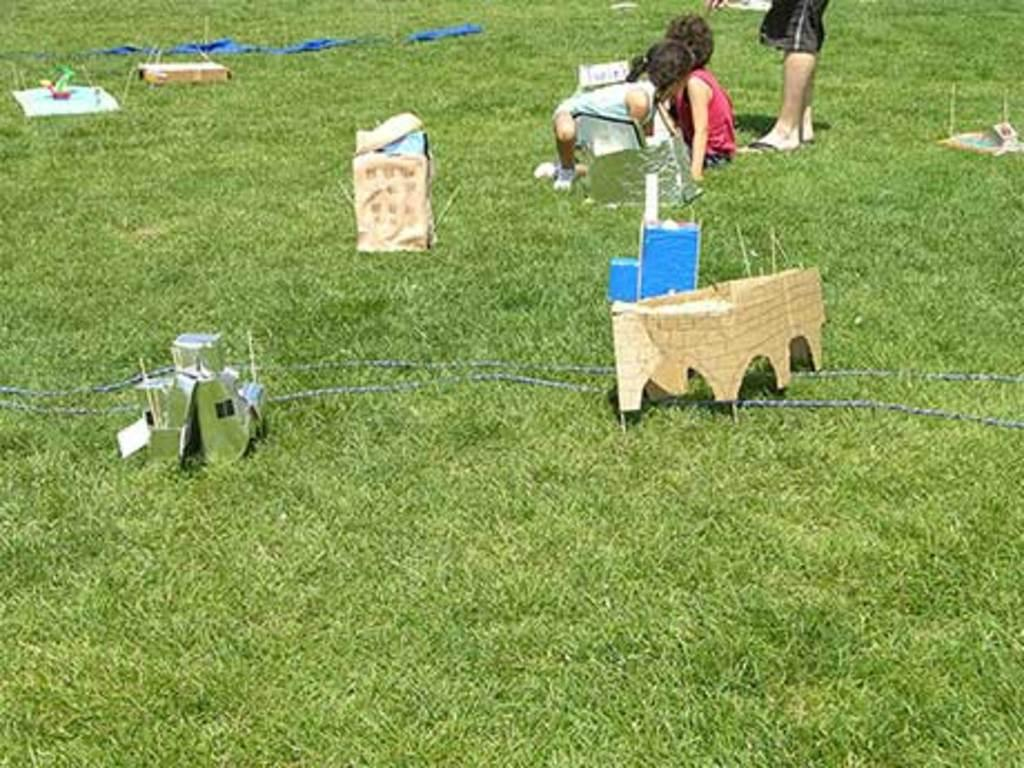How many people are in the image? There are three persons in the image. What type of structures are present in the image? There are buildings made up of cardboard in the image. What is the ground made of in the image? There is green grass at the bottom of the image. What activity are the persons engaged in with the cardboard buildings? There is no specific activity depicted in the image involving the persons and the cardboard buildings. 